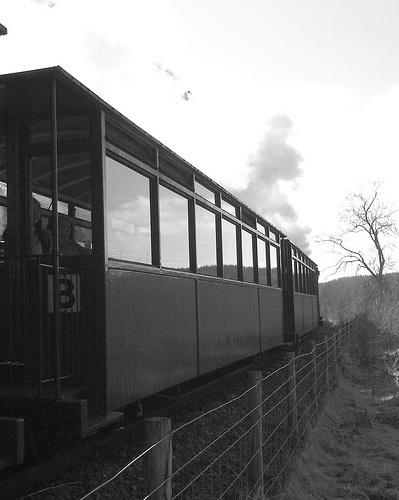Are there both a door and a window in this scene? Yes, you can see both a door and windows in the side of the train compartment visible in the image. 